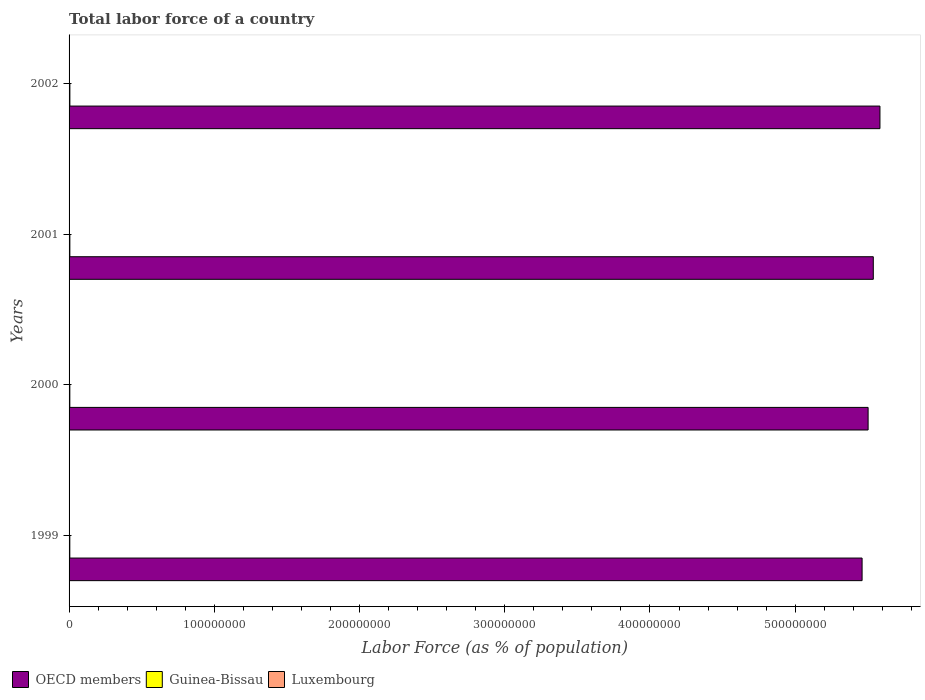How many groups of bars are there?
Provide a succinct answer. 4. How many bars are there on the 3rd tick from the top?
Make the answer very short. 3. How many bars are there on the 2nd tick from the bottom?
Keep it short and to the point. 3. What is the label of the 4th group of bars from the top?
Your response must be concise. 1999. What is the percentage of labor force in Guinea-Bissau in 2001?
Ensure brevity in your answer.  5.39e+05. Across all years, what is the maximum percentage of labor force in Luxembourg?
Provide a short and direct response. 1.95e+05. Across all years, what is the minimum percentage of labor force in Guinea-Bissau?
Ensure brevity in your answer.  5.09e+05. In which year was the percentage of labor force in Guinea-Bissau maximum?
Keep it short and to the point. 2002. What is the total percentage of labor force in Guinea-Bissau in the graph?
Give a very brief answer. 2.13e+06. What is the difference between the percentage of labor force in Guinea-Bissau in 1999 and that in 2002?
Offer a very short reply. -4.74e+04. What is the difference between the percentage of labor force in OECD members in 1999 and the percentage of labor force in Luxembourg in 2002?
Your answer should be compact. 5.46e+08. What is the average percentage of labor force in Guinea-Bissau per year?
Keep it short and to the point. 5.32e+05. In the year 2000, what is the difference between the percentage of labor force in Luxembourg and percentage of labor force in OECD members?
Provide a succinct answer. -5.50e+08. What is the ratio of the percentage of labor force in Luxembourg in 1999 to that in 2000?
Provide a succinct answer. 0.96. Is the percentage of labor force in Luxembourg in 2001 less than that in 2002?
Provide a short and direct response. Yes. Is the difference between the percentage of labor force in Luxembourg in 2001 and 2002 greater than the difference between the percentage of labor force in OECD members in 2001 and 2002?
Make the answer very short. Yes. What is the difference between the highest and the second highest percentage of labor force in Guinea-Bissau?
Ensure brevity in your answer.  1.83e+04. What is the difference between the highest and the lowest percentage of labor force in Luxembourg?
Offer a very short reply. 1.28e+04. In how many years, is the percentage of labor force in Guinea-Bissau greater than the average percentage of labor force in Guinea-Bissau taken over all years?
Ensure brevity in your answer.  2. Is the sum of the percentage of labor force in OECD members in 2001 and 2002 greater than the maximum percentage of labor force in Luxembourg across all years?
Keep it short and to the point. Yes. What does the 2nd bar from the top in 2001 represents?
Offer a very short reply. Guinea-Bissau. What does the 3rd bar from the bottom in 1999 represents?
Offer a terse response. Luxembourg. Are all the bars in the graph horizontal?
Provide a short and direct response. Yes. How many years are there in the graph?
Your answer should be very brief. 4. How are the legend labels stacked?
Offer a terse response. Horizontal. What is the title of the graph?
Your response must be concise. Total labor force of a country. What is the label or title of the X-axis?
Offer a terse response. Labor Force (as % of population). What is the label or title of the Y-axis?
Your answer should be very brief. Years. What is the Labor Force (as % of population) in OECD members in 1999?
Give a very brief answer. 5.46e+08. What is the Labor Force (as % of population) of Guinea-Bissau in 1999?
Keep it short and to the point. 5.09e+05. What is the Labor Force (as % of population) in Luxembourg in 1999?
Give a very brief answer. 1.82e+05. What is the Labor Force (as % of population) in OECD members in 2000?
Provide a short and direct response. 5.50e+08. What is the Labor Force (as % of population) of Guinea-Bissau in 2000?
Your answer should be compact. 5.23e+05. What is the Labor Force (as % of population) in Luxembourg in 2000?
Provide a short and direct response. 1.89e+05. What is the Labor Force (as % of population) in OECD members in 2001?
Make the answer very short. 5.54e+08. What is the Labor Force (as % of population) in Guinea-Bissau in 2001?
Your answer should be compact. 5.39e+05. What is the Labor Force (as % of population) in Luxembourg in 2001?
Provide a short and direct response. 1.89e+05. What is the Labor Force (as % of population) in OECD members in 2002?
Offer a terse response. 5.58e+08. What is the Labor Force (as % of population) of Guinea-Bissau in 2002?
Your answer should be compact. 5.57e+05. What is the Labor Force (as % of population) in Luxembourg in 2002?
Your response must be concise. 1.95e+05. Across all years, what is the maximum Labor Force (as % of population) in OECD members?
Your answer should be compact. 5.58e+08. Across all years, what is the maximum Labor Force (as % of population) in Guinea-Bissau?
Ensure brevity in your answer.  5.57e+05. Across all years, what is the maximum Labor Force (as % of population) of Luxembourg?
Make the answer very short. 1.95e+05. Across all years, what is the minimum Labor Force (as % of population) of OECD members?
Offer a terse response. 5.46e+08. Across all years, what is the minimum Labor Force (as % of population) in Guinea-Bissau?
Your answer should be compact. 5.09e+05. Across all years, what is the minimum Labor Force (as % of population) of Luxembourg?
Give a very brief answer. 1.82e+05. What is the total Labor Force (as % of population) of OECD members in the graph?
Provide a short and direct response. 2.21e+09. What is the total Labor Force (as % of population) in Guinea-Bissau in the graph?
Ensure brevity in your answer.  2.13e+06. What is the total Labor Force (as % of population) in Luxembourg in the graph?
Offer a very short reply. 7.54e+05. What is the difference between the Labor Force (as % of population) in OECD members in 1999 and that in 2000?
Offer a very short reply. -4.15e+06. What is the difference between the Labor Force (as % of population) in Guinea-Bissau in 1999 and that in 2000?
Keep it short and to the point. -1.38e+04. What is the difference between the Labor Force (as % of population) of Luxembourg in 1999 and that in 2000?
Ensure brevity in your answer.  -6961. What is the difference between the Labor Force (as % of population) in OECD members in 1999 and that in 2001?
Provide a short and direct response. -7.72e+06. What is the difference between the Labor Force (as % of population) of Guinea-Bissau in 1999 and that in 2001?
Keep it short and to the point. -2.91e+04. What is the difference between the Labor Force (as % of population) of Luxembourg in 1999 and that in 2001?
Make the answer very short. -7108. What is the difference between the Labor Force (as % of population) of OECD members in 1999 and that in 2002?
Make the answer very short. -1.23e+07. What is the difference between the Labor Force (as % of population) of Guinea-Bissau in 1999 and that in 2002?
Your response must be concise. -4.74e+04. What is the difference between the Labor Force (as % of population) in Luxembourg in 1999 and that in 2002?
Ensure brevity in your answer.  -1.28e+04. What is the difference between the Labor Force (as % of population) of OECD members in 2000 and that in 2001?
Offer a terse response. -3.57e+06. What is the difference between the Labor Force (as % of population) of Guinea-Bissau in 2000 and that in 2001?
Give a very brief answer. -1.53e+04. What is the difference between the Labor Force (as % of population) in Luxembourg in 2000 and that in 2001?
Offer a very short reply. -147. What is the difference between the Labor Force (as % of population) of OECD members in 2000 and that in 2002?
Ensure brevity in your answer.  -8.15e+06. What is the difference between the Labor Force (as % of population) of Guinea-Bissau in 2000 and that in 2002?
Provide a short and direct response. -3.36e+04. What is the difference between the Labor Force (as % of population) of Luxembourg in 2000 and that in 2002?
Ensure brevity in your answer.  -5841. What is the difference between the Labor Force (as % of population) of OECD members in 2001 and that in 2002?
Ensure brevity in your answer.  -4.58e+06. What is the difference between the Labor Force (as % of population) of Guinea-Bissau in 2001 and that in 2002?
Your response must be concise. -1.83e+04. What is the difference between the Labor Force (as % of population) in Luxembourg in 2001 and that in 2002?
Give a very brief answer. -5694. What is the difference between the Labor Force (as % of population) in OECD members in 1999 and the Labor Force (as % of population) in Guinea-Bissau in 2000?
Provide a succinct answer. 5.46e+08. What is the difference between the Labor Force (as % of population) of OECD members in 1999 and the Labor Force (as % of population) of Luxembourg in 2000?
Your answer should be very brief. 5.46e+08. What is the difference between the Labor Force (as % of population) in Guinea-Bissau in 1999 and the Labor Force (as % of population) in Luxembourg in 2000?
Ensure brevity in your answer.  3.21e+05. What is the difference between the Labor Force (as % of population) of OECD members in 1999 and the Labor Force (as % of population) of Guinea-Bissau in 2001?
Your response must be concise. 5.46e+08. What is the difference between the Labor Force (as % of population) in OECD members in 1999 and the Labor Force (as % of population) in Luxembourg in 2001?
Give a very brief answer. 5.46e+08. What is the difference between the Labor Force (as % of population) of Guinea-Bissau in 1999 and the Labor Force (as % of population) of Luxembourg in 2001?
Offer a very short reply. 3.20e+05. What is the difference between the Labor Force (as % of population) of OECD members in 1999 and the Labor Force (as % of population) of Guinea-Bissau in 2002?
Offer a terse response. 5.45e+08. What is the difference between the Labor Force (as % of population) in OECD members in 1999 and the Labor Force (as % of population) in Luxembourg in 2002?
Your answer should be very brief. 5.46e+08. What is the difference between the Labor Force (as % of population) in Guinea-Bissau in 1999 and the Labor Force (as % of population) in Luxembourg in 2002?
Your answer should be very brief. 3.15e+05. What is the difference between the Labor Force (as % of population) in OECD members in 2000 and the Labor Force (as % of population) in Guinea-Bissau in 2001?
Offer a very short reply. 5.50e+08. What is the difference between the Labor Force (as % of population) of OECD members in 2000 and the Labor Force (as % of population) of Luxembourg in 2001?
Provide a short and direct response. 5.50e+08. What is the difference between the Labor Force (as % of population) in Guinea-Bissau in 2000 and the Labor Force (as % of population) in Luxembourg in 2001?
Keep it short and to the point. 3.34e+05. What is the difference between the Labor Force (as % of population) of OECD members in 2000 and the Labor Force (as % of population) of Guinea-Bissau in 2002?
Ensure brevity in your answer.  5.50e+08. What is the difference between the Labor Force (as % of population) of OECD members in 2000 and the Labor Force (as % of population) of Luxembourg in 2002?
Your answer should be very brief. 5.50e+08. What is the difference between the Labor Force (as % of population) in Guinea-Bissau in 2000 and the Labor Force (as % of population) in Luxembourg in 2002?
Your response must be concise. 3.28e+05. What is the difference between the Labor Force (as % of population) in OECD members in 2001 and the Labor Force (as % of population) in Guinea-Bissau in 2002?
Keep it short and to the point. 5.53e+08. What is the difference between the Labor Force (as % of population) in OECD members in 2001 and the Labor Force (as % of population) in Luxembourg in 2002?
Keep it short and to the point. 5.54e+08. What is the difference between the Labor Force (as % of population) in Guinea-Bissau in 2001 and the Labor Force (as % of population) in Luxembourg in 2002?
Ensure brevity in your answer.  3.44e+05. What is the average Labor Force (as % of population) of OECD members per year?
Offer a very short reply. 5.52e+08. What is the average Labor Force (as % of population) of Guinea-Bissau per year?
Your answer should be very brief. 5.32e+05. What is the average Labor Force (as % of population) in Luxembourg per year?
Your answer should be compact. 1.89e+05. In the year 1999, what is the difference between the Labor Force (as % of population) of OECD members and Labor Force (as % of population) of Guinea-Bissau?
Offer a very short reply. 5.46e+08. In the year 1999, what is the difference between the Labor Force (as % of population) of OECD members and Labor Force (as % of population) of Luxembourg?
Give a very brief answer. 5.46e+08. In the year 1999, what is the difference between the Labor Force (as % of population) in Guinea-Bissau and Labor Force (as % of population) in Luxembourg?
Your response must be concise. 3.28e+05. In the year 2000, what is the difference between the Labor Force (as % of population) in OECD members and Labor Force (as % of population) in Guinea-Bissau?
Offer a terse response. 5.50e+08. In the year 2000, what is the difference between the Labor Force (as % of population) in OECD members and Labor Force (as % of population) in Luxembourg?
Ensure brevity in your answer.  5.50e+08. In the year 2000, what is the difference between the Labor Force (as % of population) of Guinea-Bissau and Labor Force (as % of population) of Luxembourg?
Your response must be concise. 3.34e+05. In the year 2001, what is the difference between the Labor Force (as % of population) in OECD members and Labor Force (as % of population) in Guinea-Bissau?
Your answer should be compact. 5.53e+08. In the year 2001, what is the difference between the Labor Force (as % of population) in OECD members and Labor Force (as % of population) in Luxembourg?
Your answer should be very brief. 5.54e+08. In the year 2001, what is the difference between the Labor Force (as % of population) in Guinea-Bissau and Labor Force (as % of population) in Luxembourg?
Ensure brevity in your answer.  3.50e+05. In the year 2002, what is the difference between the Labor Force (as % of population) of OECD members and Labor Force (as % of population) of Guinea-Bissau?
Offer a terse response. 5.58e+08. In the year 2002, what is the difference between the Labor Force (as % of population) of OECD members and Labor Force (as % of population) of Luxembourg?
Offer a very short reply. 5.58e+08. In the year 2002, what is the difference between the Labor Force (as % of population) in Guinea-Bissau and Labor Force (as % of population) in Luxembourg?
Ensure brevity in your answer.  3.62e+05. What is the ratio of the Labor Force (as % of population) in OECD members in 1999 to that in 2000?
Offer a very short reply. 0.99. What is the ratio of the Labor Force (as % of population) of Guinea-Bissau in 1999 to that in 2000?
Your answer should be very brief. 0.97. What is the ratio of the Labor Force (as % of population) of Luxembourg in 1999 to that in 2000?
Provide a succinct answer. 0.96. What is the ratio of the Labor Force (as % of population) of OECD members in 1999 to that in 2001?
Make the answer very short. 0.99. What is the ratio of the Labor Force (as % of population) of Guinea-Bissau in 1999 to that in 2001?
Ensure brevity in your answer.  0.95. What is the ratio of the Labor Force (as % of population) of Luxembourg in 1999 to that in 2001?
Keep it short and to the point. 0.96. What is the ratio of the Labor Force (as % of population) in OECD members in 1999 to that in 2002?
Offer a very short reply. 0.98. What is the ratio of the Labor Force (as % of population) in Guinea-Bissau in 1999 to that in 2002?
Keep it short and to the point. 0.92. What is the ratio of the Labor Force (as % of population) in Luxembourg in 1999 to that in 2002?
Keep it short and to the point. 0.93. What is the ratio of the Labor Force (as % of population) of Guinea-Bissau in 2000 to that in 2001?
Keep it short and to the point. 0.97. What is the ratio of the Labor Force (as % of population) in Luxembourg in 2000 to that in 2001?
Offer a terse response. 1. What is the ratio of the Labor Force (as % of population) of OECD members in 2000 to that in 2002?
Provide a succinct answer. 0.99. What is the ratio of the Labor Force (as % of population) in Guinea-Bissau in 2000 to that in 2002?
Your response must be concise. 0.94. What is the ratio of the Labor Force (as % of population) of Luxembourg in 2000 to that in 2002?
Provide a short and direct response. 0.97. What is the ratio of the Labor Force (as % of population) in OECD members in 2001 to that in 2002?
Keep it short and to the point. 0.99. What is the ratio of the Labor Force (as % of population) in Guinea-Bissau in 2001 to that in 2002?
Provide a succinct answer. 0.97. What is the ratio of the Labor Force (as % of population) in Luxembourg in 2001 to that in 2002?
Offer a very short reply. 0.97. What is the difference between the highest and the second highest Labor Force (as % of population) in OECD members?
Keep it short and to the point. 4.58e+06. What is the difference between the highest and the second highest Labor Force (as % of population) of Guinea-Bissau?
Provide a short and direct response. 1.83e+04. What is the difference between the highest and the second highest Labor Force (as % of population) of Luxembourg?
Provide a short and direct response. 5694. What is the difference between the highest and the lowest Labor Force (as % of population) of OECD members?
Ensure brevity in your answer.  1.23e+07. What is the difference between the highest and the lowest Labor Force (as % of population) of Guinea-Bissau?
Provide a short and direct response. 4.74e+04. What is the difference between the highest and the lowest Labor Force (as % of population) of Luxembourg?
Your answer should be compact. 1.28e+04. 